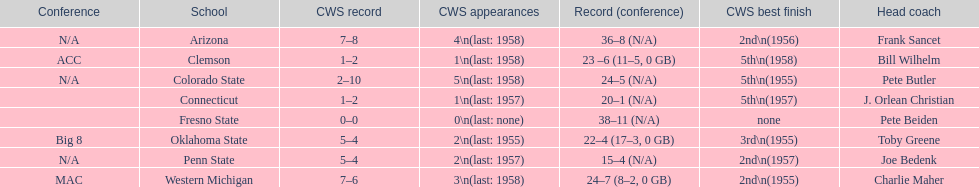What are the number of schools with more than 2 cws appearances? 3. 